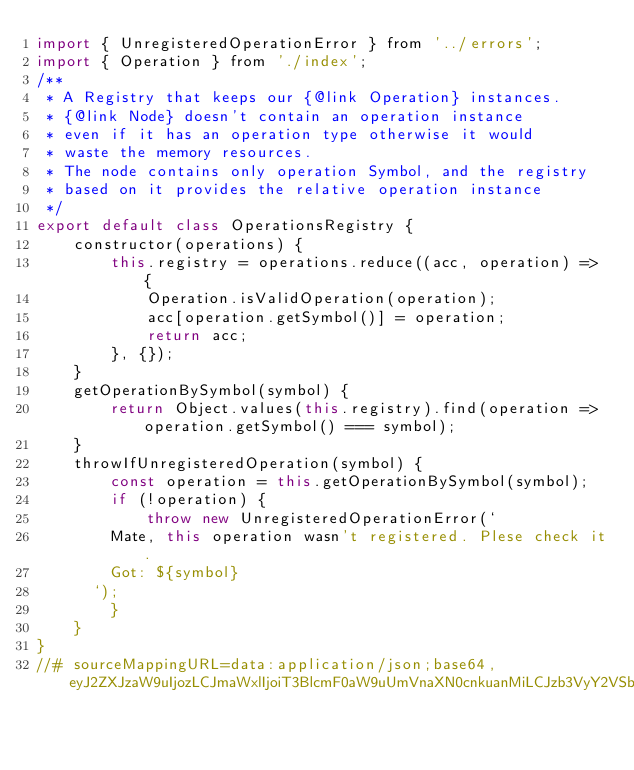Convert code to text. <code><loc_0><loc_0><loc_500><loc_500><_JavaScript_>import { UnregisteredOperationError } from '../errors';
import { Operation } from './index';
/**
 * A Registry that keeps our {@link Operation} instances.
 * {@link Node} doesn't contain an operation instance
 * even if it has an operation type otherwise it would
 * waste the memory resources.
 * The node contains only operation Symbol, and the registry
 * based on it provides the relative operation instance
 */
export default class OperationsRegistry {
    constructor(operations) {
        this.registry = operations.reduce((acc, operation) => {
            Operation.isValidOperation(operation);
            acc[operation.getSymbol()] = operation;
            return acc;
        }, {});
    }
    getOperationBySymbol(symbol) {
        return Object.values(this.registry).find(operation => operation.getSymbol() === symbol);
    }
    throwIfUnregisteredOperation(symbol) {
        const operation = this.getOperationBySymbol(symbol);
        if (!operation) {
            throw new UnregisteredOperationError(`
        Mate, this operation wasn't registered. Plese check it.
        Got: ${symbol}
      `);
        }
    }
}
//# sourceMappingURL=data:application/json;base64,eyJ2ZXJzaW9uIjozLCJmaWxlIjoiT3BlcmF0aW9uUmVnaXN0cnkuanMiLCJzb3VyY2VSb290IjoiIiwic291cmNlcyI6WyIuLi8uLi8uLi9zcmMvb3BlcmF0aW9ucy9PcGVyYXRpb25SZWdpc3RyeS50cyJdLCJuYW1lcyI6W10sIm1hcHBpbmdzIjoiQUFBQSxPQUFPLEVBQUUsMEJBQTBCLEVBQUUsTUFBTSxXQUFXLENBQUM7QUFDdkQsT0FBTyxFQUFFLFNBQVMsRUFBRSxNQUFNLFNBQVMsQ0FBQztBQU1wQzs7Ozs7OztHQU9HO0FBQ0gsTUFBTSxDQUFDLE9BQU8sT0FBTyxrQkFBa0I7SUFHckMsWUFBWSxVQUF1QjtRQUNqQyxJQUFJLENBQUMsUUFBUSxHQUFHLFVBQVUsQ0FBQyxNQUFNLENBQy9CLENBQUMsR0FBaUIsRUFBRSxTQUFvQixFQUFFLEVBQUU7WUFDMUMsU0FBUyxDQUFDLGdCQUFnQixDQUFDLFNBQVMsQ0FBQyxDQUFDO1lBRXRDLEdBQUcsQ0FBQyxTQUFTLENBQUMsU0FBUyxFQUFFLENBQUMsR0FBRyxTQUFTLENBQUM7WUFDdkMsT0FBTyxHQUFHLENBQUM7UUFDYixDQUFDLEVBQ0QsRUFBRSxDQUNILENBQUM7SUFDSixDQUFDO0lBRU0sb0JBQW9CLENBQUMsTUFBYztRQUN4QyxPQUFPLE1BQU0sQ0FBQyxNQUFNLENBQUMsSUFBSSxDQUFDLFFBQVEsQ0FBQyxDQUFDLElBQUksQ0FDdEMsU0FBUyxDQUFDLEVBQUUsQ0FBQyxTQUFTLENBQUMsU0FBUyxFQUFFLEtBQUssTUFBTSxDQUM5QyxDQUFDO0lBQ0osQ0FBQztJQUVNLDRCQUE0QixDQUFDLE1BQWM7UUFDaEQsTUFBTSxTQUFTLEdBQUcsSUFBSSxDQUFDLG9CQUFvQixDQUFDLE1BQU0sQ0FBQyxDQUFDO1FBQ3BELElBQUksQ0FBQyxTQUFTLEVBQUU7WUFDZCxNQUFNLElBQUksMEJBQTBCLENBQUM7O2VBRTVCLE1BQU07T0FDZCxDQUFDLENBQUM7U0FDSjtJQUNILENBQUM7Q0FDRiJ9</code> 